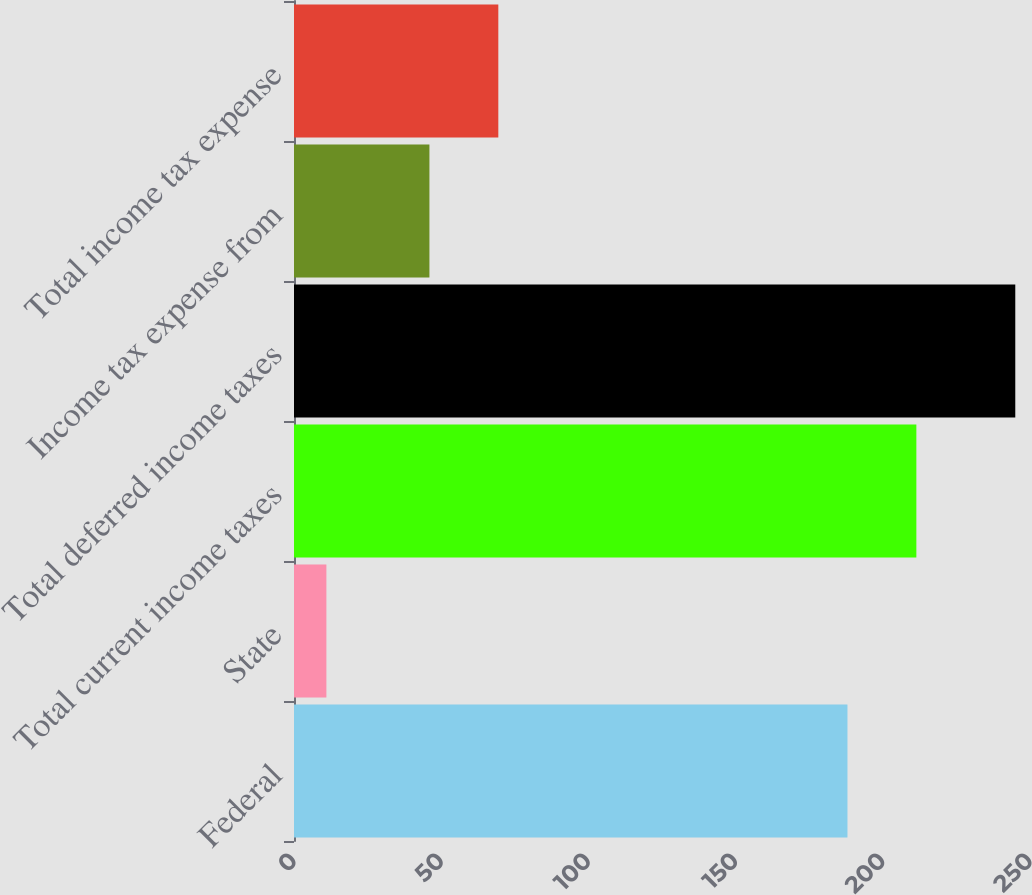Convert chart to OTSL. <chart><loc_0><loc_0><loc_500><loc_500><bar_chart><fcel>Federal<fcel>State<fcel>Total current income taxes<fcel>Total deferred income taxes<fcel>Income tax expense from<fcel>Total income tax expense<nl><fcel>188<fcel>11<fcel>211.4<fcel>245<fcel>46<fcel>69.4<nl></chart> 